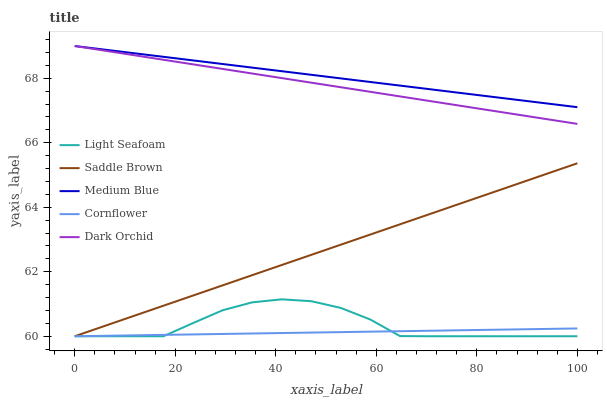Does Cornflower have the minimum area under the curve?
Answer yes or no. Yes. Does Medium Blue have the maximum area under the curve?
Answer yes or no. Yes. Does Light Seafoam have the minimum area under the curve?
Answer yes or no. No. Does Light Seafoam have the maximum area under the curve?
Answer yes or no. No. Is Medium Blue the smoothest?
Answer yes or no. Yes. Is Light Seafoam the roughest?
Answer yes or no. Yes. Is Light Seafoam the smoothest?
Answer yes or no. No. Is Medium Blue the roughest?
Answer yes or no. No. Does Cornflower have the lowest value?
Answer yes or no. Yes. Does Medium Blue have the lowest value?
Answer yes or no. No. Does Dark Orchid have the highest value?
Answer yes or no. Yes. Does Light Seafoam have the highest value?
Answer yes or no. No. Is Saddle Brown less than Medium Blue?
Answer yes or no. Yes. Is Medium Blue greater than Saddle Brown?
Answer yes or no. Yes. Does Saddle Brown intersect Cornflower?
Answer yes or no. Yes. Is Saddle Brown less than Cornflower?
Answer yes or no. No. Is Saddle Brown greater than Cornflower?
Answer yes or no. No. Does Saddle Brown intersect Medium Blue?
Answer yes or no. No. 